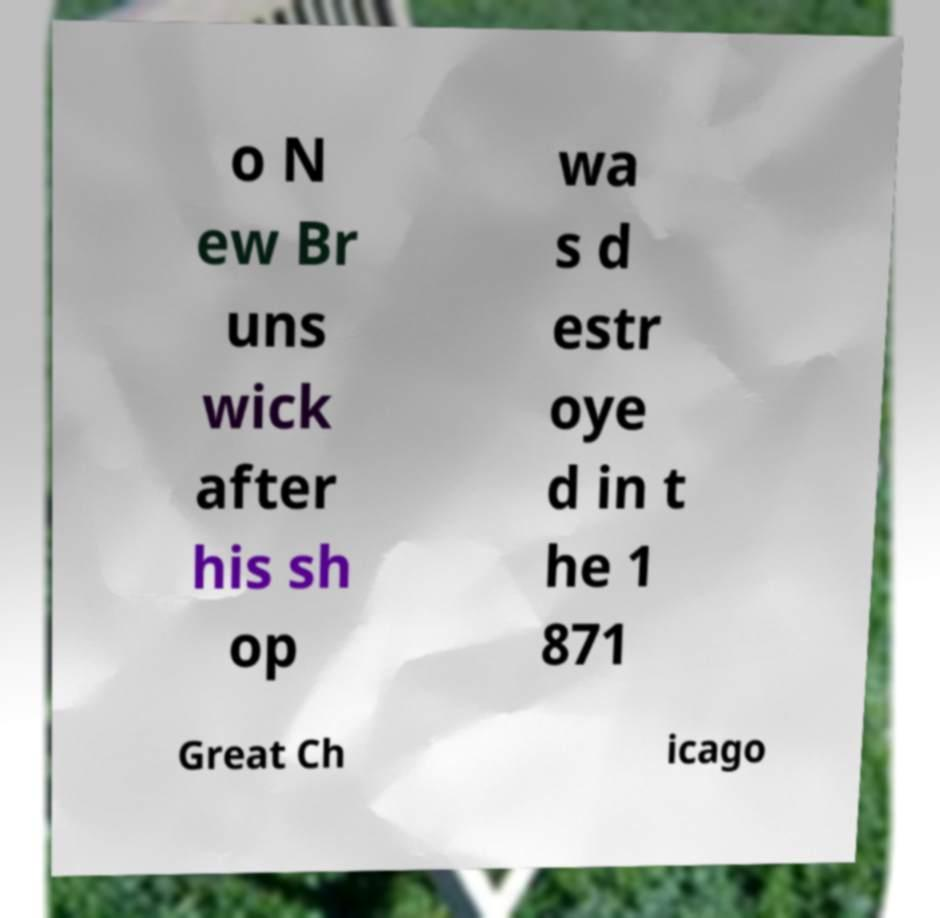Could you assist in decoding the text presented in this image and type it out clearly? o N ew Br uns wick after his sh op wa s d estr oye d in t he 1 871 Great Ch icago 